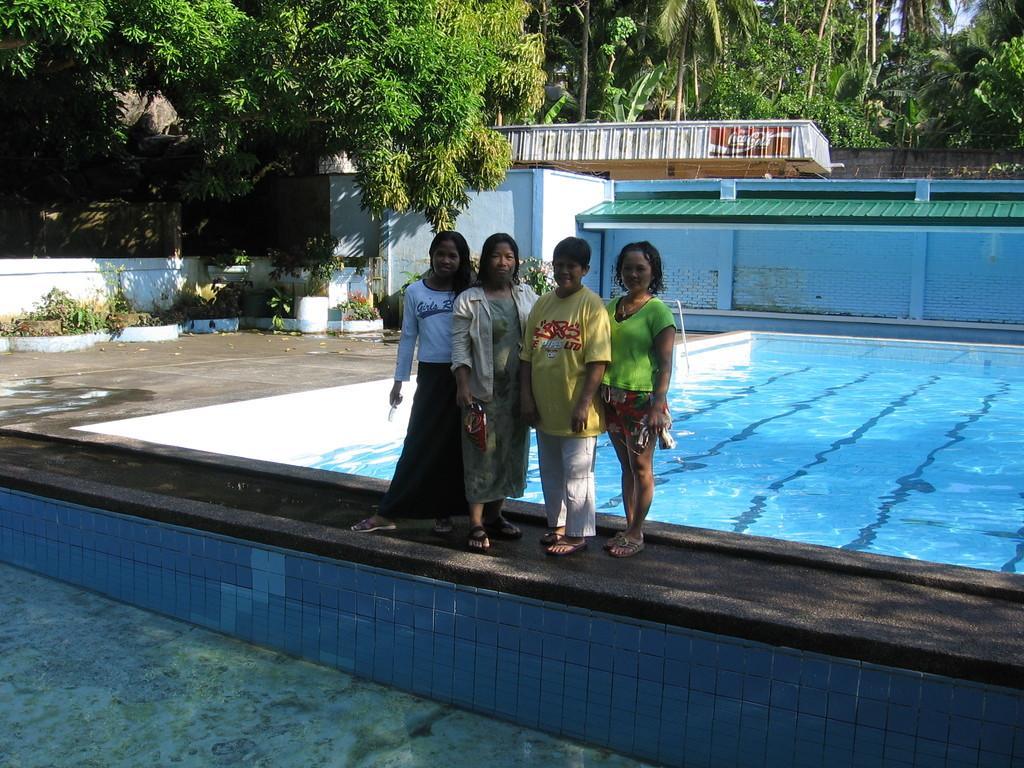Please provide a concise description of this image. In this image there is a woman and three kids standing in front of a swimming pool and posing for the camera, behind them there is a swimming pool with water in it, behind the swimming pool there are trees. 